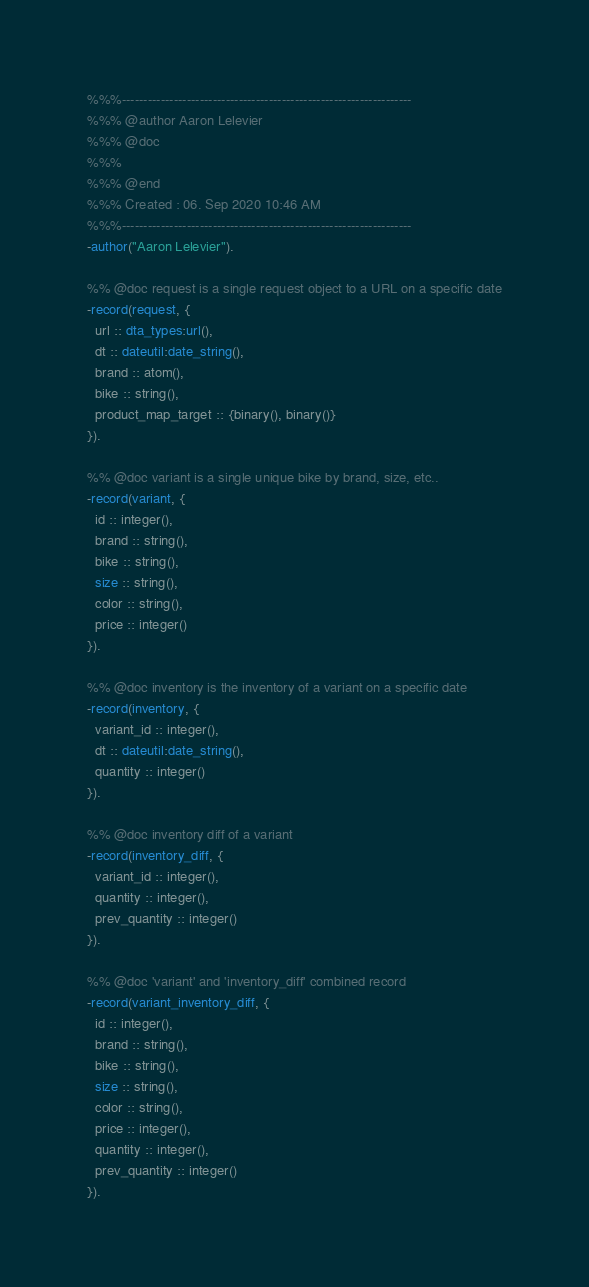Convert code to text. <code><loc_0><loc_0><loc_500><loc_500><_Erlang_>%%%-------------------------------------------------------------------
%%% @author Aaron Lelevier
%%% @doc
%%%
%%% @end
%%% Created : 06. Sep 2020 10:46 AM
%%%-------------------------------------------------------------------
-author("Aaron Lelevier").

%% @doc request is a single request object to a URL on a specific date
-record(request, {
  url :: dta_types:url(),
  dt :: dateutil:date_string(),
  brand :: atom(),
  bike :: string(),
  product_map_target :: {binary(), binary()}
}).

%% @doc variant is a single unique bike by brand, size, etc..
-record(variant, {
  id :: integer(),
  brand :: string(),
  bike :: string(),
  size :: string(),
  color :: string(),
  price :: integer()
}).

%% @doc inventory is the inventory of a variant on a specific date
-record(inventory, {
  variant_id :: integer(),
  dt :: dateutil:date_string(),
  quantity :: integer()
}).

%% @doc inventory diff of a variant
-record(inventory_diff, {
  variant_id :: integer(),
  quantity :: integer(),
  prev_quantity :: integer()
}).

%% @doc 'variant' and 'inventory_diff' combined record
-record(variant_inventory_diff, {
  id :: integer(),
  brand :: string(),
  bike :: string(),
  size :: string(),
  color :: string(),
  price :: integer(),
  quantity :: integer(),
  prev_quantity :: integer()
}).</code> 